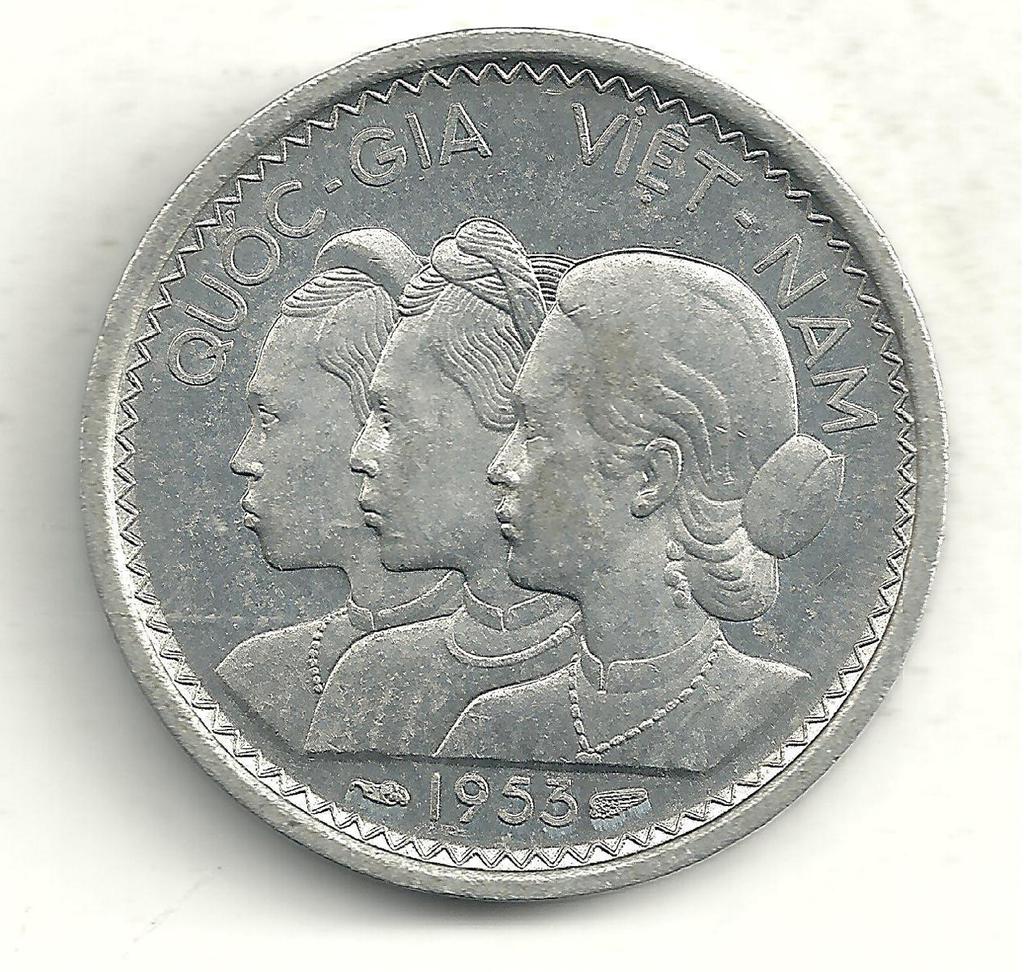What year is on this vietnam coin?
Provide a short and direct response. 1953. What country is this coin from?
Offer a terse response. Vietnam. 